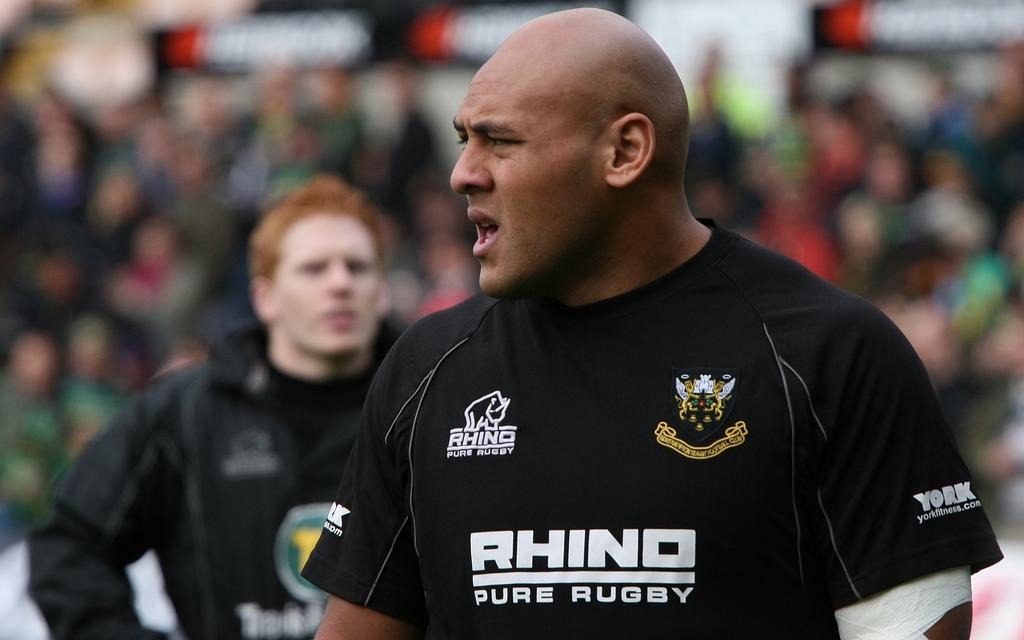<image>
Summarize the visual content of the image. A bald man in a black Rhino Pure Rugby shirt is in front of a crowd. 